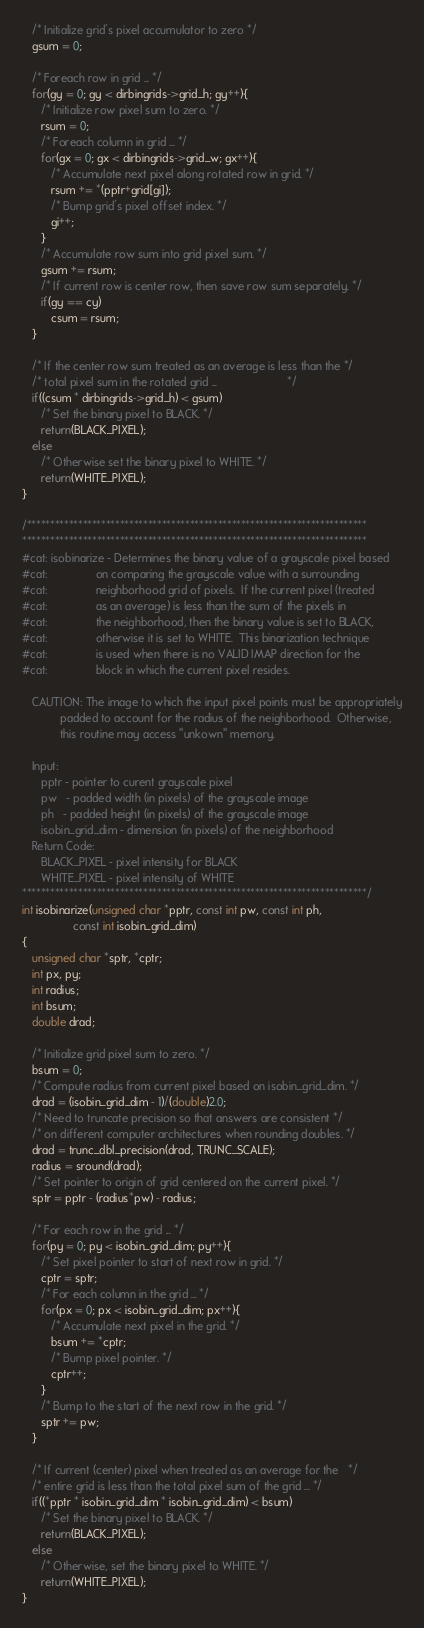Convert code to text. <code><loc_0><loc_0><loc_500><loc_500><_C_>   /* Initialize grid's pixel accumulator to zero */
   gsum = 0;

   /* Foreach row in grid ... */
   for(gy = 0; gy < dirbingrids->grid_h; gy++){
      /* Initialize row pixel sum to zero. */
      rsum = 0;
      /* Foreach column in grid ... */
      for(gx = 0; gx < dirbingrids->grid_w; gx++){
         /* Accumulate next pixel along rotated row in grid. */
         rsum += *(pptr+grid[gi]);
         /* Bump grid's pixel offset index. */
         gi++;
      }
      /* Accumulate row sum into grid pixel sum. */
      gsum += rsum;
      /* If current row is center row, then save row sum separately. */
      if(gy == cy)
         csum = rsum;
   }

   /* If the center row sum treated as an average is less than the */
   /* total pixel sum in the rotated grid ...                      */
   if((csum * dirbingrids->grid_h) < gsum)
      /* Set the binary pixel to BLACK. */
      return(BLACK_PIXEL);
   else
      /* Otherwise set the binary pixel to WHITE. */
      return(WHITE_PIXEL);
}

/*************************************************************************
**************************************************************************
#cat: isobinarize - Determines the binary value of a grayscale pixel based
#cat:               on comparing the grayscale value with a surrounding
#cat:               neighborhood grid of pixels.  If the current pixel (treated
#cat:               as an average) is less than the sum of the pixels in
#cat:               the neighborhood, then the binary value is set to BLACK,
#cat:               otherwise it is set to WHITE.  This binarization technique
#cat:               is used when there is no VALID IMAP direction for the
#cat:               block in which the current pixel resides.

   CAUTION: The image to which the input pixel points must be appropriately
            padded to account for the radius of the neighborhood.  Otherwise,
            this routine may access "unkown" memory.

   Input:
      pptr - pointer to curent grayscale pixel
      pw   - padded width (in pixels) of the grayscale image
      ph   - padded height (in pixels) of the grayscale image
      isobin_grid_dim - dimension (in pixels) of the neighborhood
   Return Code:
      BLACK_PIXEL - pixel intensity for BLACK
      WHITE_PIXEL - pixel intensity of WHITE
**************************************************************************/
int isobinarize(unsigned char *pptr, const int pw, const int ph,
                const int isobin_grid_dim)
{
   unsigned char *sptr, *cptr;
   int px, py;
   int radius;
   int bsum;
   double drad;

   /* Initialize grid pixel sum to zero. */
   bsum = 0;
   /* Compute radius from current pixel based on isobin_grid_dim. */
   drad = (isobin_grid_dim - 1)/(double)2.0;
   /* Need to truncate precision so that answers are consistent */
   /* on different computer architectures when rounding doubles. */
   drad = trunc_dbl_precision(drad, TRUNC_SCALE);
   radius = sround(drad);
   /* Set pointer to origin of grid centered on the current pixel. */
   sptr = pptr - (radius*pw) - radius;

   /* For each row in the grid ... */
   for(py = 0; py < isobin_grid_dim; py++){
      /* Set pixel pointer to start of next row in grid. */
      cptr = sptr;
      /* For each column in the grid ... */
      for(px = 0; px < isobin_grid_dim; px++){
         /* Accumulate next pixel in the grid. */
         bsum += *cptr;
         /* Bump pixel pointer. */
         cptr++;
      }
      /* Bump to the start of the next row in the grid. */
      sptr += pw;
   }

   /* If current (center) pixel when treated as an average for the   */
   /* entire grid is less than the total pixel sum of the grid ... */
   if((*pptr * isobin_grid_dim * isobin_grid_dim) < bsum)
      /* Set the binary pixel to BLACK. */
      return(BLACK_PIXEL);
   else
      /* Otherwise, set the binary pixel to WHITE. */
      return(WHITE_PIXEL);
}
</code> 